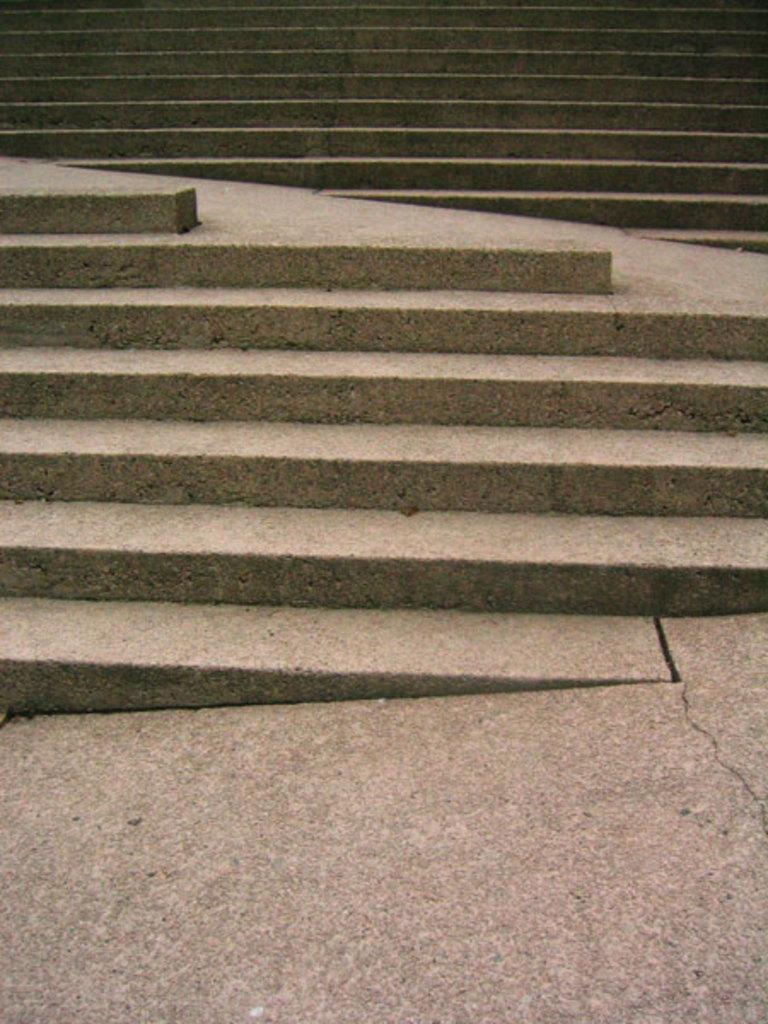What type of structure is present in the image? There is a staircase in the image. What material is the surface at the bottom of the image made of? The surface at the bottom of the image is made of stone. Can you observe any plastic items in the image? There is no mention of plastic items in the image, so we cannot determine if any are present. 